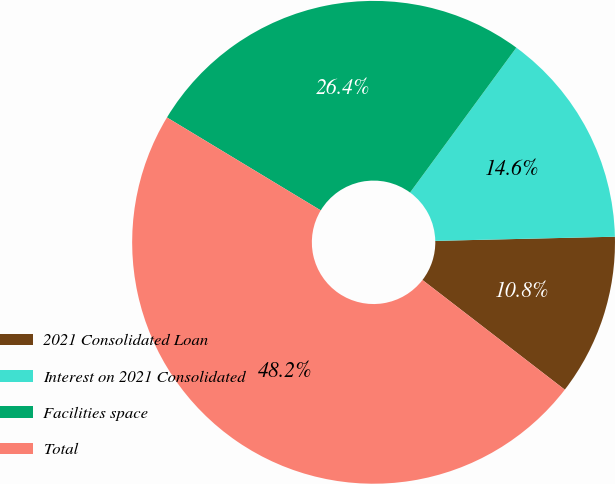<chart> <loc_0><loc_0><loc_500><loc_500><pie_chart><fcel>2021 Consolidated Loan<fcel>Interest on 2021 Consolidated<fcel>Facilities space<fcel>Total<nl><fcel>10.82%<fcel>14.56%<fcel>26.42%<fcel>48.2%<nl></chart> 